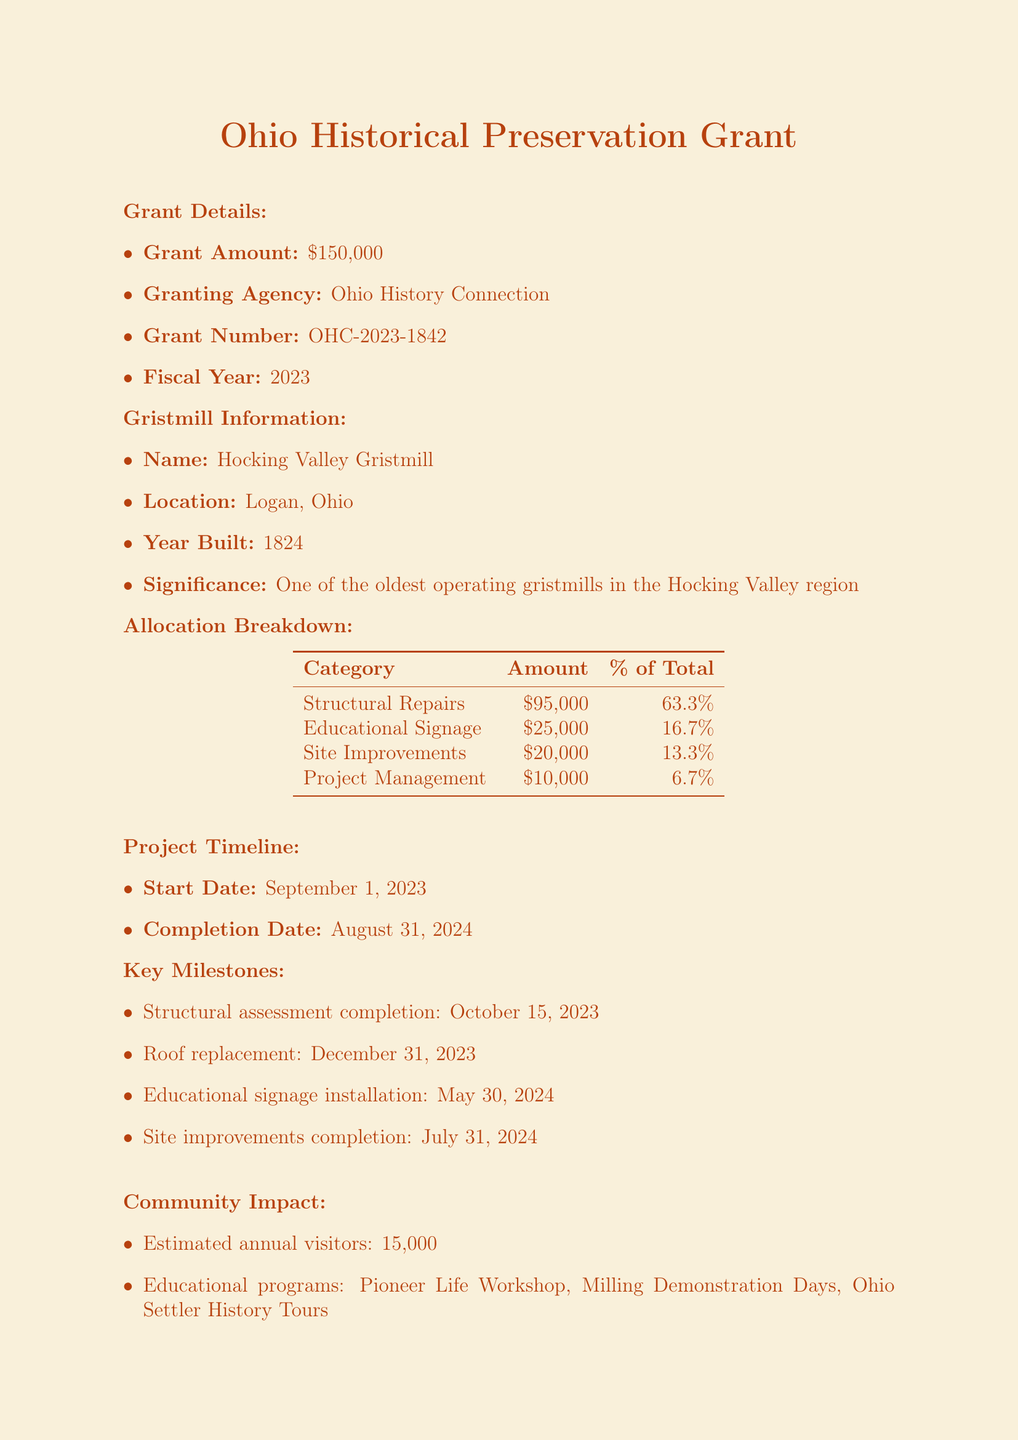What is the grant amount? The grant amount is specified in the grant details section of the document.
Answer: $150,000 Who is the granting agency? This can be found in the grant details section, which lists the agency providing the grant.
Answer: Ohio History Connection What is the name of the gristmill? The name of the gristmill is detailed in the gristmill information section.
Answer: Hocking Valley Gristmill What is the total amount allocated for structural repairs? The total amount for structural repairs is found in the allocation breakdown section.
Answer: $95,000 When is the completion date of the project? The completion date is listed in the project timeline section of the document.
Answer: August 31, 2024 How many estimated annual visitors are expected? This information is specified in the community impact section, which details visitor projections.
Answer: 15,000 What percent of the total grant is allocated to educational signage? The percentage allocated can be calculated using the total amounts in the allocation breakdown section.
Answer: 16.7% What is the first key milestone listed in the document? The first key milestone can be found in the project timeline section where all milestones are listed.
Answer: Structural assessment completion What will the maintenance fund amount to? The document specifies the amount allocated for the maintenance fund in the sustainability plan section.
Answer: $20,000 